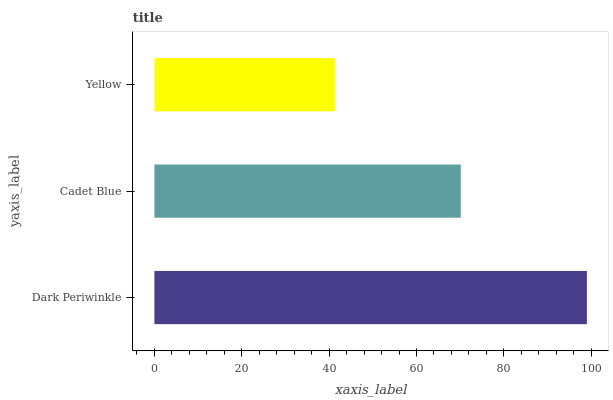Is Yellow the minimum?
Answer yes or no. Yes. Is Dark Periwinkle the maximum?
Answer yes or no. Yes. Is Cadet Blue the minimum?
Answer yes or no. No. Is Cadet Blue the maximum?
Answer yes or no. No. Is Dark Periwinkle greater than Cadet Blue?
Answer yes or no. Yes. Is Cadet Blue less than Dark Periwinkle?
Answer yes or no. Yes. Is Cadet Blue greater than Dark Periwinkle?
Answer yes or no. No. Is Dark Periwinkle less than Cadet Blue?
Answer yes or no. No. Is Cadet Blue the high median?
Answer yes or no. Yes. Is Cadet Blue the low median?
Answer yes or no. Yes. Is Yellow the high median?
Answer yes or no. No. Is Dark Periwinkle the low median?
Answer yes or no. No. 